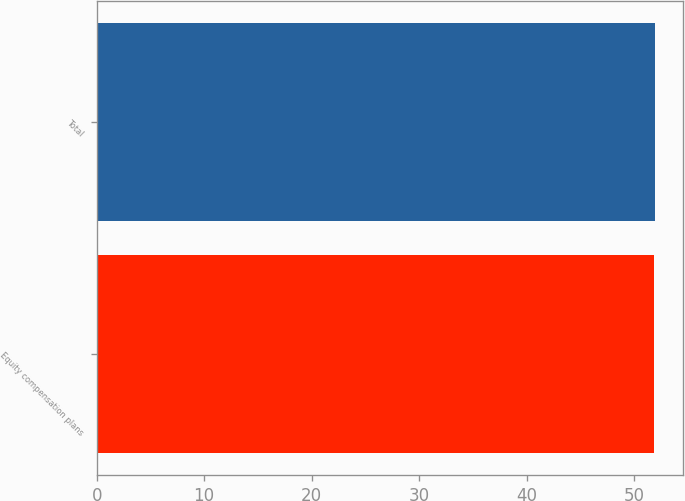<chart> <loc_0><loc_0><loc_500><loc_500><bar_chart><fcel>Equity compensation plans<fcel>Total<nl><fcel>51.85<fcel>51.95<nl></chart> 